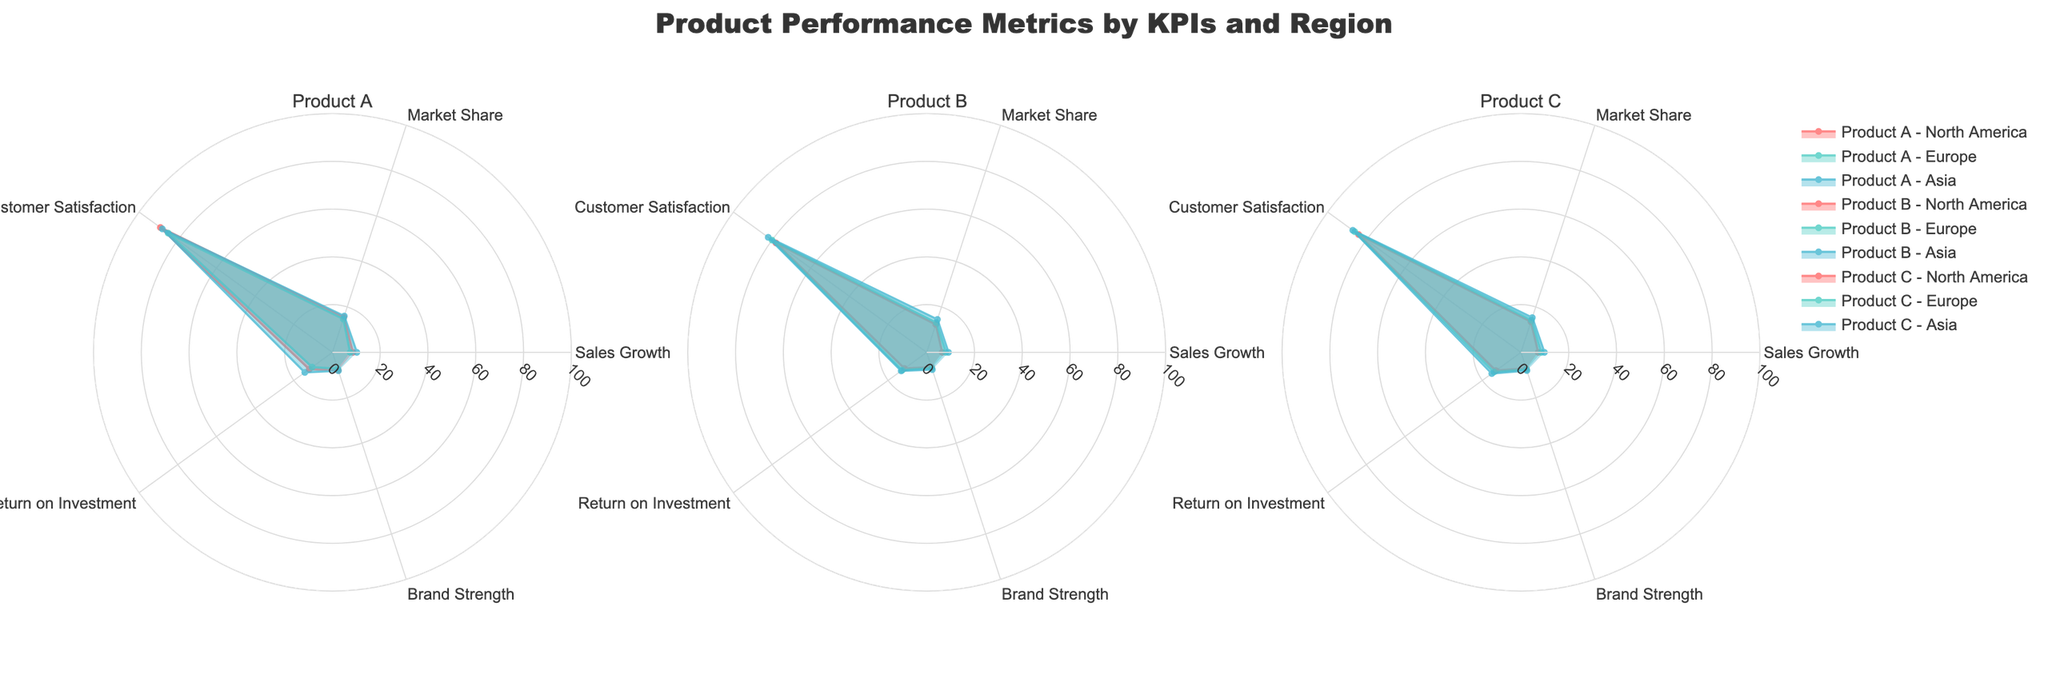Which product has the highest sales growth in Asia? Look for the radar chart related to Asia in each subplot and compare the Sales Growth metrics for all products. Product A in the Asia region has the highest sales growth rate shown.
Answer: Product A Which region shows the highest customer satisfaction for Product C? Compare the Customer Satisfaction values for Product C across all regions by examining the respective radar charts. Asia shows the highest Customer Satisfaction for Product C.
Answer: Asia What is the average Brand Strength of Product B across all regions? Extract Brand Strength values from each region's radar chart for Product B (6.5, 6.9, 7.6), sum them up and divide by the number of regions: (6.5 + 6.9 + 7.6) / 3 = 7.
Answer: 7 Which Product has the smallest Return on Investment in Europe? Compare the Return on Investment values from the Europe segment for all products. Product A has the smallest value.
Answer: Product A How does the Market Share for Product A in North America compare to Europe? Check the Market Share values for Product A in both North America and Europe and compare them. North America has a slightly higher Market Share (15.4 vs. 14.7).
Answer: North America is slightly higher Which region shows the lowest Sales Growth for Product C? Extract the Sales Growth data for Product C from each regional radar chart. North America has the lowest Sales Growth rate for Product C.
Answer: North America Across all products, which KPIs are consistently highest in the Asia region? By inspecting the Asia segment for all subplots, identify which KPIs maintain high values compared to others. Sales Growth and Brand Strength are consistently high across all products in Asia.
Answer: Sales Growth and Brand Strength Which Product and region combination shows the highest Return on Investment (ROI)? Check the ROI values across all radar charts and identify the highest one. Product C in Asia has the highest ROI at 15.1.
Answer: Product C in Asia By how much does Customer Satisfaction for Product B in Europe exceed that in North America? Compare the Customer Satisfaction metrics for Product B between Europe (80) and North America (78). The difference is 80 - 78 = 2.
Answer: 2 Which region most prominently boosts the overall average Customer Satisfaction for Product A? Calculate the average Customer Satisfaction for Product A across all regions, and compare each region's value against this average. Asia has Customer Satisfaction scores consistently high enough to boost the overall average more prominently than other regions.
Answer: Asia 